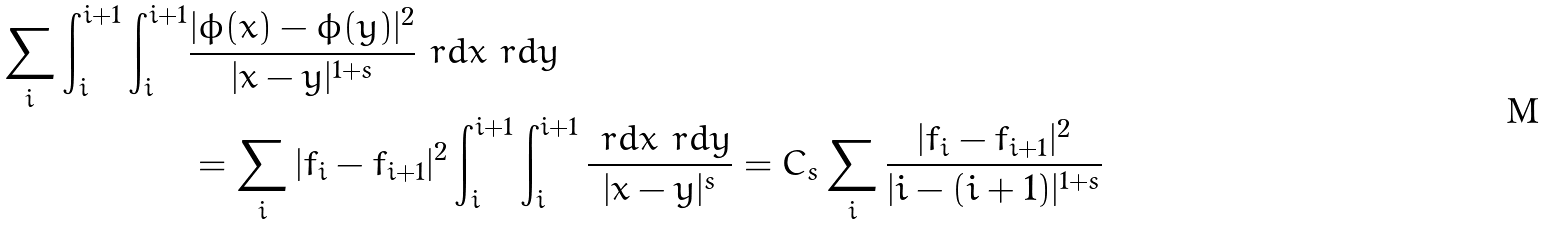Convert formula to latex. <formula><loc_0><loc_0><loc_500><loc_500>\sum _ { i } \int _ { i } ^ { i + 1 } \int _ { i } ^ { i + 1 } & \frac { | \phi ( x ) - \phi ( y ) | ^ { 2 } } { | x - y | ^ { 1 + s } } \ r d x \ r d y \\ & = \sum _ { i } | f _ { i } - f _ { i + 1 } | ^ { 2 } \int _ { i } ^ { i + 1 } \int _ { i } ^ { i + 1 } \frac { \ r d x \ r d y } { | x - y | ^ { s } } = C _ { s } \sum _ { i } \frac { | f _ { i } - f _ { i + 1 } | ^ { 2 } } { | i - ( i + 1 ) | ^ { 1 + s } }</formula> 